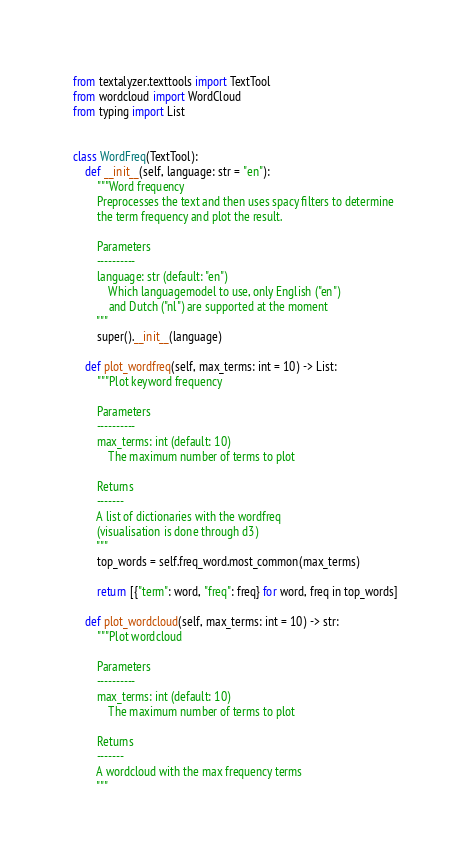Convert code to text. <code><loc_0><loc_0><loc_500><loc_500><_Python_>from textalyzer.texttools import TextTool
from wordcloud import WordCloud
from typing import List


class WordFreq(TextTool):
    def __init__(self, language: str = "en"):
        """Word frequency
        Preprocesses the text and then uses spacy filters to determine
        the term frequency and plot the result.

        Parameters
        ----------
        language: str (default: "en")
            Which languagemodel to use, only English ("en")
            and Dutch ("nl") are supported at the moment
        """
        super().__init__(language)

    def plot_wordfreq(self, max_terms: int = 10) -> List:
        """Plot keyword frequency

        Parameters
        ----------
        max_terms: int (default: 10)
            The maximum number of terms to plot

        Returns
        -------
        A list of dictionaries with the wordfreq
        (visualisation is done through d3)
        """
        top_words = self.freq_word.most_common(max_terms)

        return [{"term": word, "freq": freq} for word, freq in top_words]

    def plot_wordcloud(self, max_terms: int = 10) -> str:
        """Plot wordcloud

        Parameters
        ----------
        max_terms: int (default: 10)
            The maximum number of terms to plot

        Returns
        -------
        A wordcloud with the max frequency terms
        """</code> 